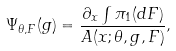Convert formula to latex. <formula><loc_0><loc_0><loc_500><loc_500>\Psi _ { \theta , F } ( g ) = \frac { \partial _ { x } \int \pi _ { 1 } ( d F ) } { A ( x ; \theta , g , F ) } ,</formula> 